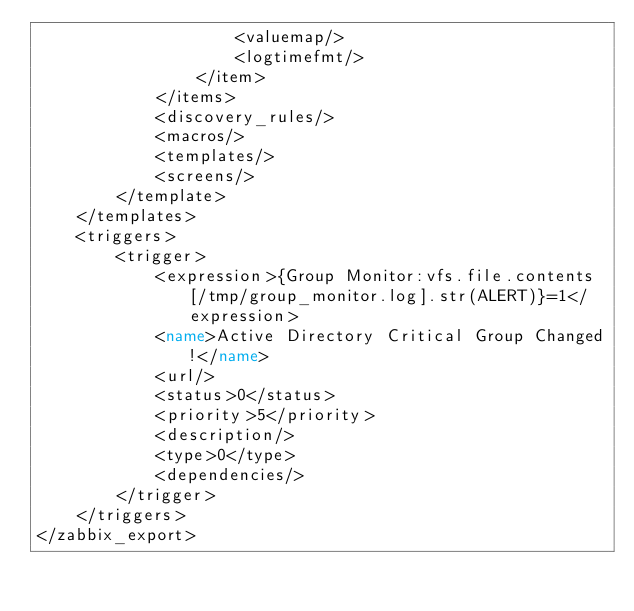Convert code to text. <code><loc_0><loc_0><loc_500><loc_500><_XML_>                    <valuemap/>
                    <logtimefmt/>
                </item>
            </items>
            <discovery_rules/>
            <macros/>
            <templates/>
            <screens/>
        </template>
    </templates>
    <triggers>
        <trigger>
            <expression>{Group Monitor:vfs.file.contents[/tmp/group_monitor.log].str(ALERT)}=1</expression>
            <name>Active Directory Critical Group Changed!</name>
            <url/>
            <status>0</status>
            <priority>5</priority>
            <description/>
            <type>0</type>
            <dependencies/>
        </trigger>
    </triggers>
</zabbix_export>
</code> 